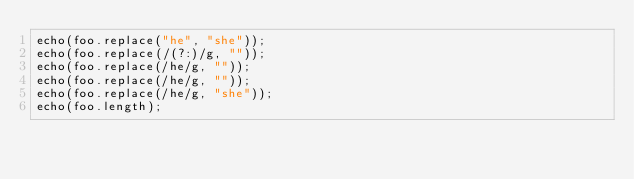<code> <loc_0><loc_0><loc_500><loc_500><_JavaScript_>echo(foo.replace("he", "she"));
echo(foo.replace(/(?:)/g, ""));
echo(foo.replace(/he/g, ""));
echo(foo.replace(/he/g, ""));
echo(foo.replace(/he/g, "she"));
echo(foo.length);
</code> 